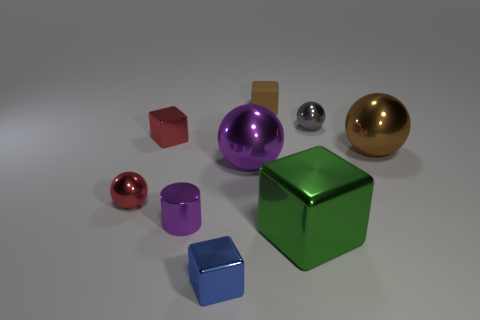Is there any other thing that is the same material as the small brown thing?
Ensure brevity in your answer.  No. What is the tiny cube on the right side of the blue metallic object made of?
Ensure brevity in your answer.  Rubber. Are there any other tiny rubber things of the same shape as the tiny purple thing?
Offer a terse response. No. How many red objects are the same shape as the big brown object?
Give a very brief answer. 1. Does the brown thing on the right side of the gray sphere have the same size as the shiny cube that is on the right side of the tiny blue shiny thing?
Offer a very short reply. Yes. There is a purple metal thing that is behind the tiny shiny sphere that is on the left side of the purple cylinder; what shape is it?
Provide a succinct answer. Sphere. Are there an equal number of green shiny blocks that are on the left side of the brown matte block and green cubes?
Provide a short and direct response. No. What material is the small sphere to the right of the red object that is in front of the brown object in front of the tiny rubber cube made of?
Your response must be concise. Metal. Is there a matte sphere that has the same size as the gray metal sphere?
Keep it short and to the point. No. The small matte object has what shape?
Offer a very short reply. Cube. 